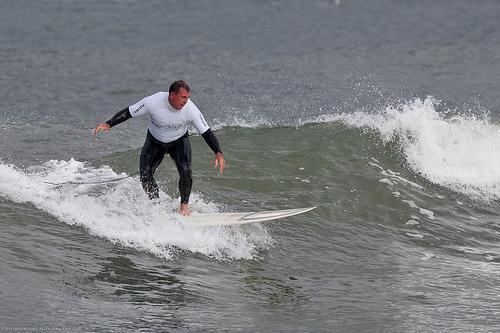How many people in the water?
Give a very brief answer. 1. 